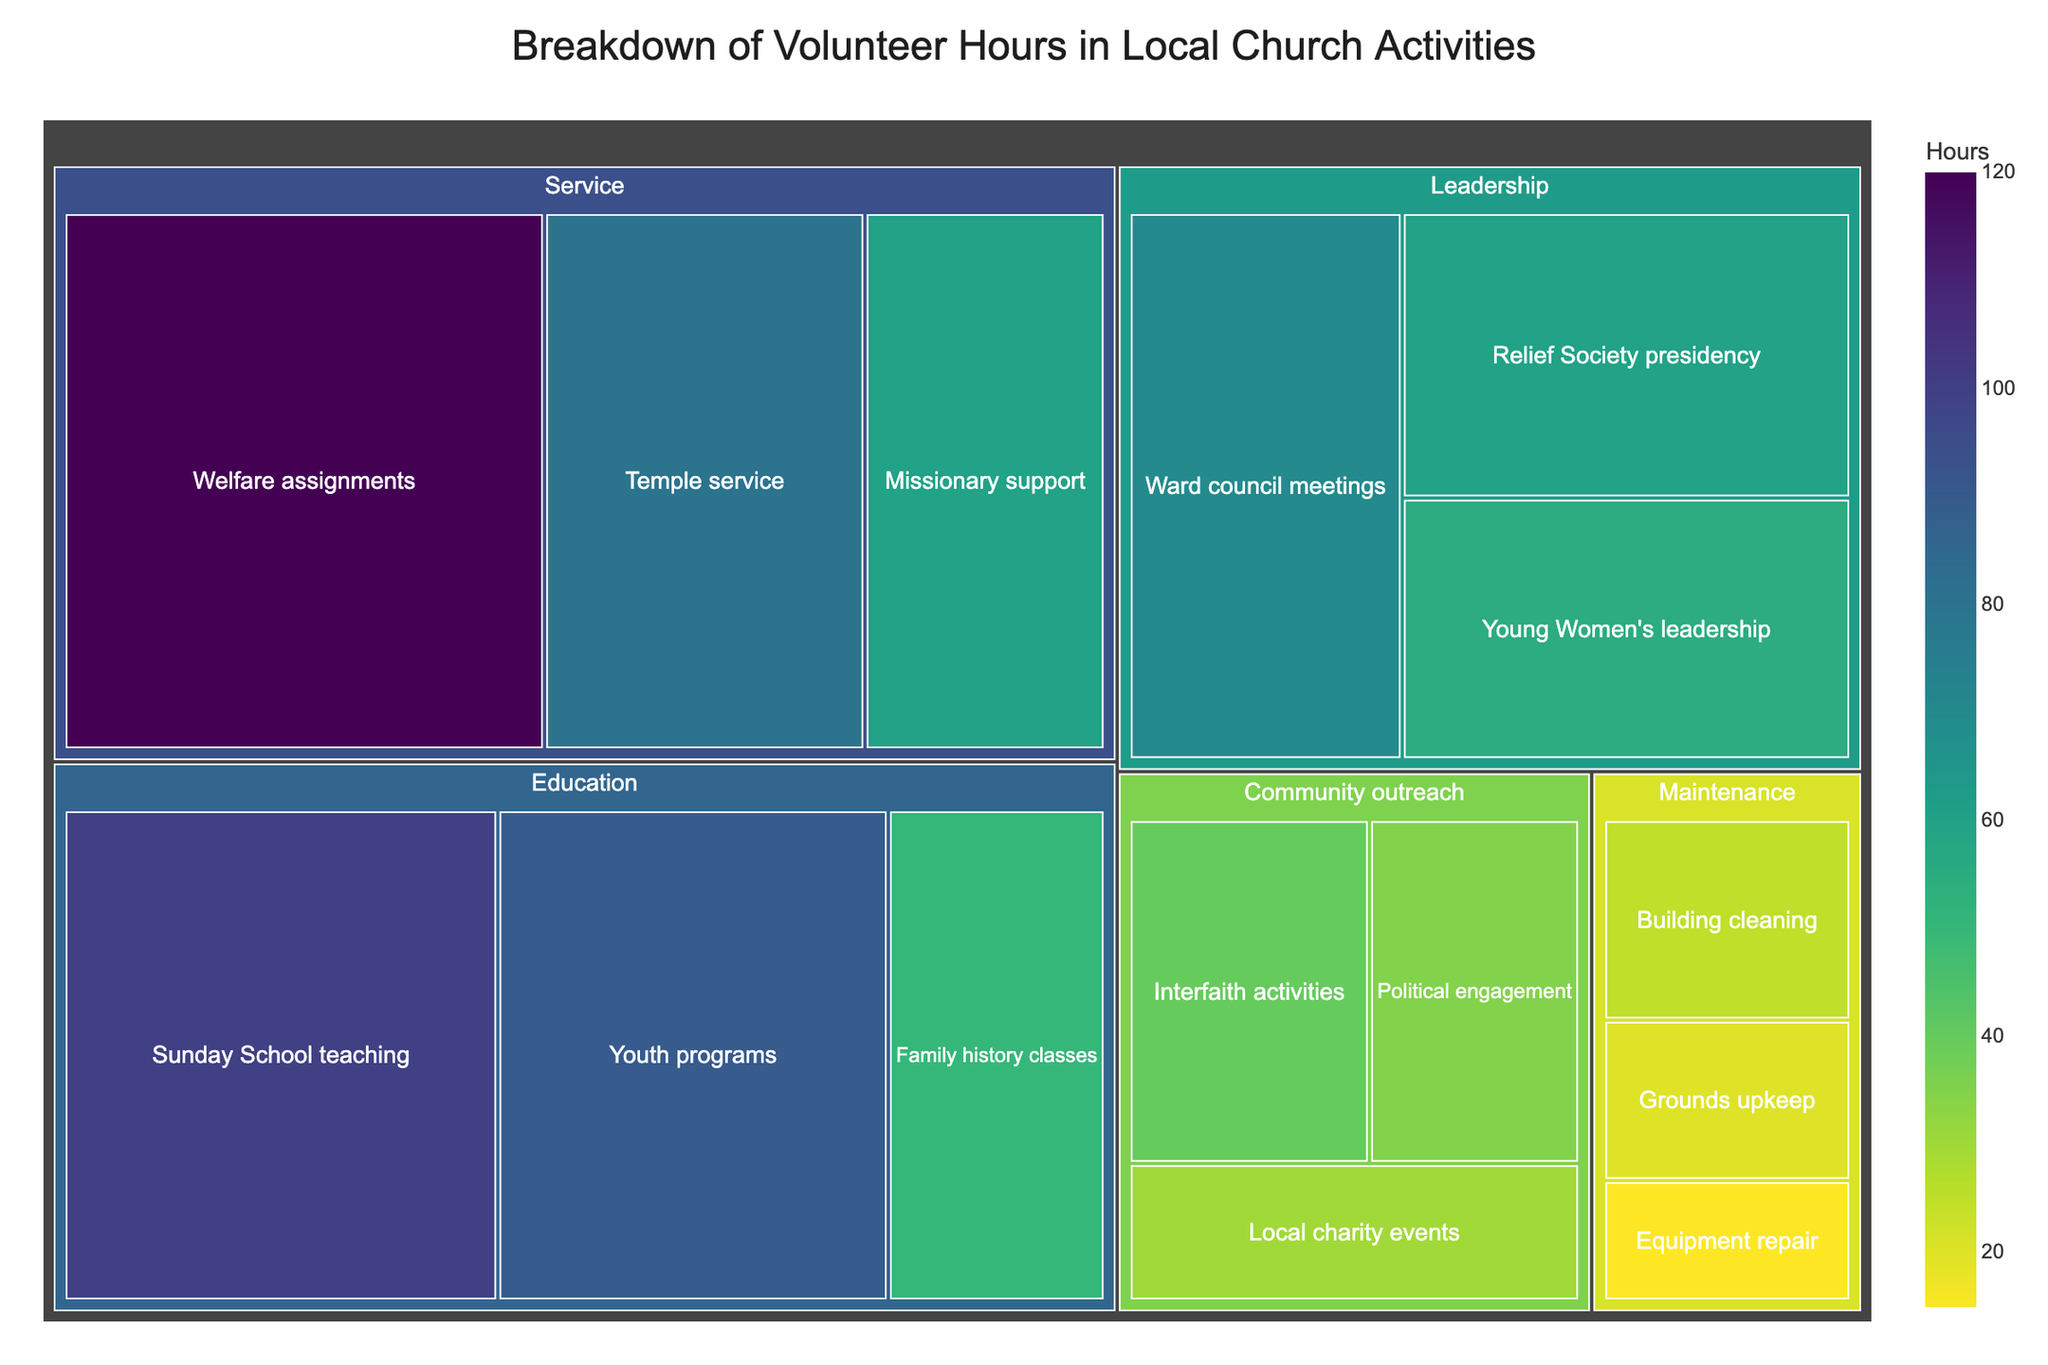What is the title of the figure? The title is typically located at the top of the figure and is meant to describe what the figure is about.
Answer: Breakdown of Volunteer Hours in Local Church Activities Which category has the most volunteer hours? In a treemap, the size of each rectangle is proportional to the value it represents; larger rectangles represent higher values.
Answer: Service How many hours are allocated to 'Youth programs'? The exact numbers can be found by either looking for the label or hovering over the specific rectangle in the treemap if it is interactive.
Answer: 90 What is the total number of volunteer hours dedicated to the 'Community outreach' category? Find the individual hours for each subcategory under 'Community outreach' and sum them: Interfaith activities (40) + Political engagement (35) + Local charity events (30).
Answer: 105 Compare the volunteer hours between 'Relief Society presidency' and 'Young Women's leadership'. Which one has more hours? Look at the rectangles corresponding to 'Relief Society presidency' and 'Young Women's leadership', and compare their values.
Answer: Relief Society presidency What is the combined number of hours for all activities under the 'Maintenance' category? Add the hours of each subcategory within the 'Maintenance' category: Building cleaning (25) + Grounds upkeep (20) + Equipment repair (15).
Answer: 60 Which subcategory within 'Service' has the smallest number of hours? Identify the subcategories within 'Service' and compare their hours to find the smallest one.
Answer: Missionary support Between 'Sunday School teaching' and 'Temple service', which has more volunteer hours and by how much? Compare the hours for 'Sunday School teaching' (100) and 'Temple service' (80). Subtract the smaller number from the larger one to find the difference.
Answer: Sunday School teaching by 20 hours What is the aggregate number of hours for all activities in the 'Leadership' category? Add the hours for each subcategory under 'Leadership': Ward council meetings (70) + Relief Society presidency (60) + Young Women's leadership (55).
Answer: 185 Is 'Political engagement' among the top three subcategories with the least volunteer hours? Find the hours of all subcategories and sort them in ascending order. Identify if 'Political engagement' (35) is within the top three smallest values.
Answer: No 